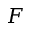<formula> <loc_0><loc_0><loc_500><loc_500>F</formula> 